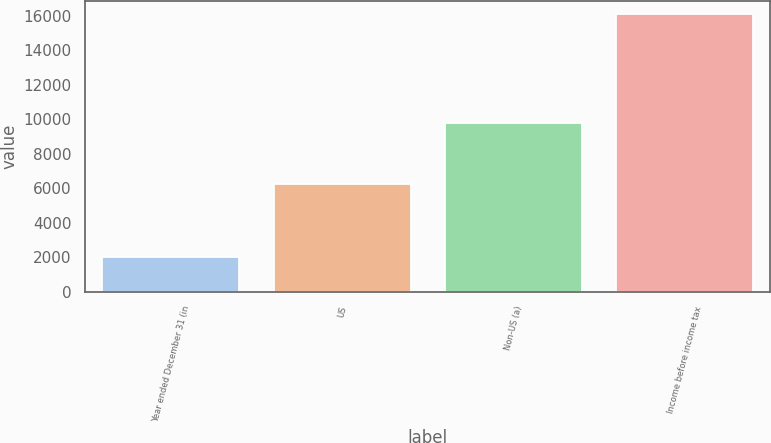<chart> <loc_0><loc_0><loc_500><loc_500><bar_chart><fcel>Year ended December 31 (in<fcel>US<fcel>Non-US (a)<fcel>Income before income tax<nl><fcel>2009<fcel>6263<fcel>9804<fcel>16067<nl></chart> 